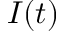Convert formula to latex. <formula><loc_0><loc_0><loc_500><loc_500>I ( t )</formula> 